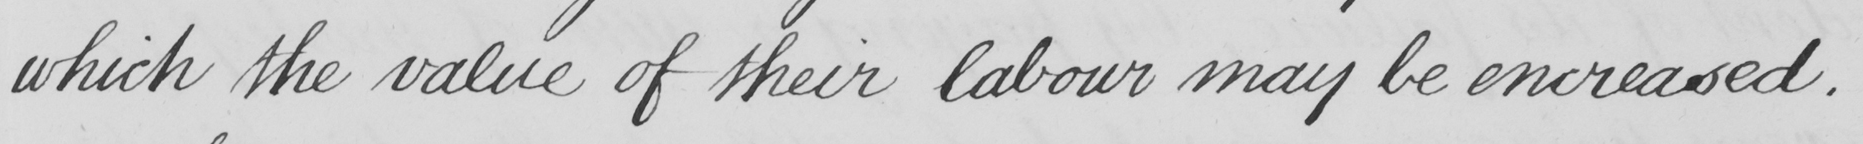Can you read and transcribe this handwriting? which the value of their labour may be encreased . 